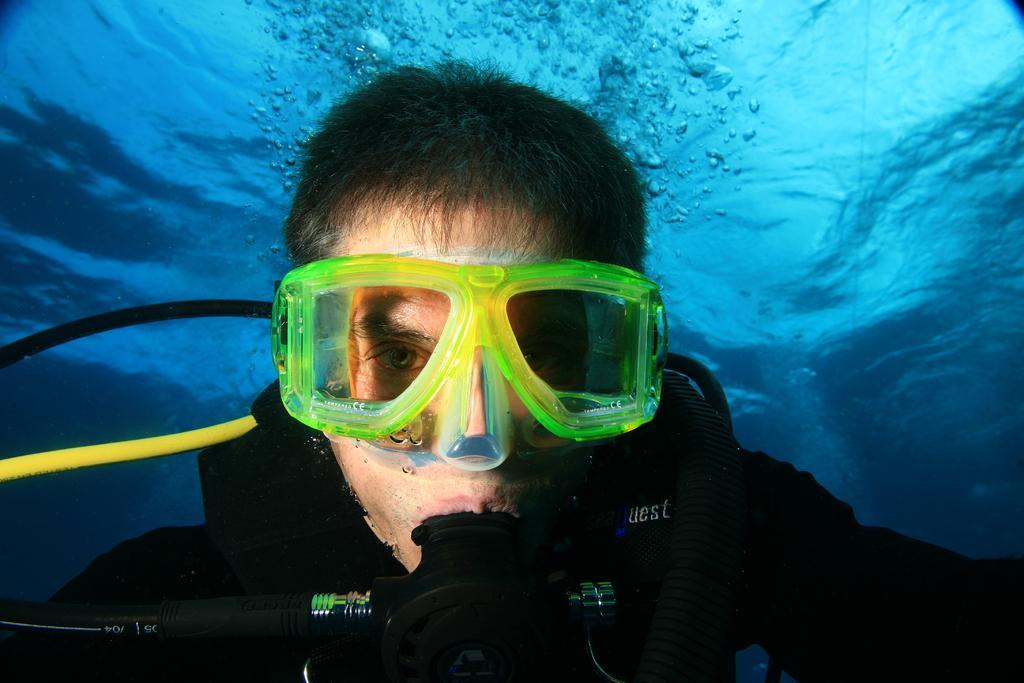In one or two sentences, can you explain what this image depicts? In this picture we can see a man in the water, and he wore spectacles. 